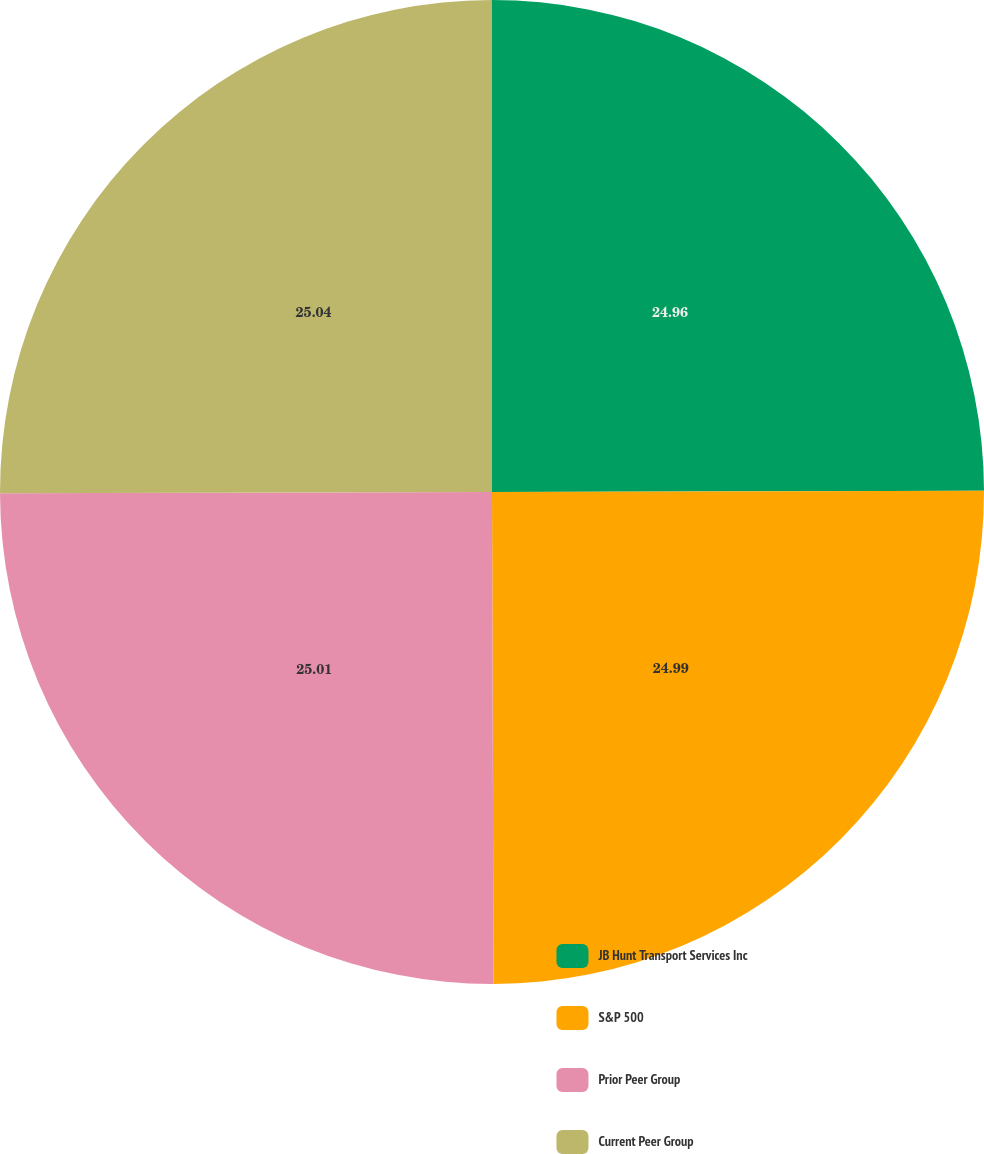Convert chart to OTSL. <chart><loc_0><loc_0><loc_500><loc_500><pie_chart><fcel>JB Hunt Transport Services Inc<fcel>S&P 500<fcel>Prior Peer Group<fcel>Current Peer Group<nl><fcel>24.96%<fcel>24.99%<fcel>25.01%<fcel>25.04%<nl></chart> 